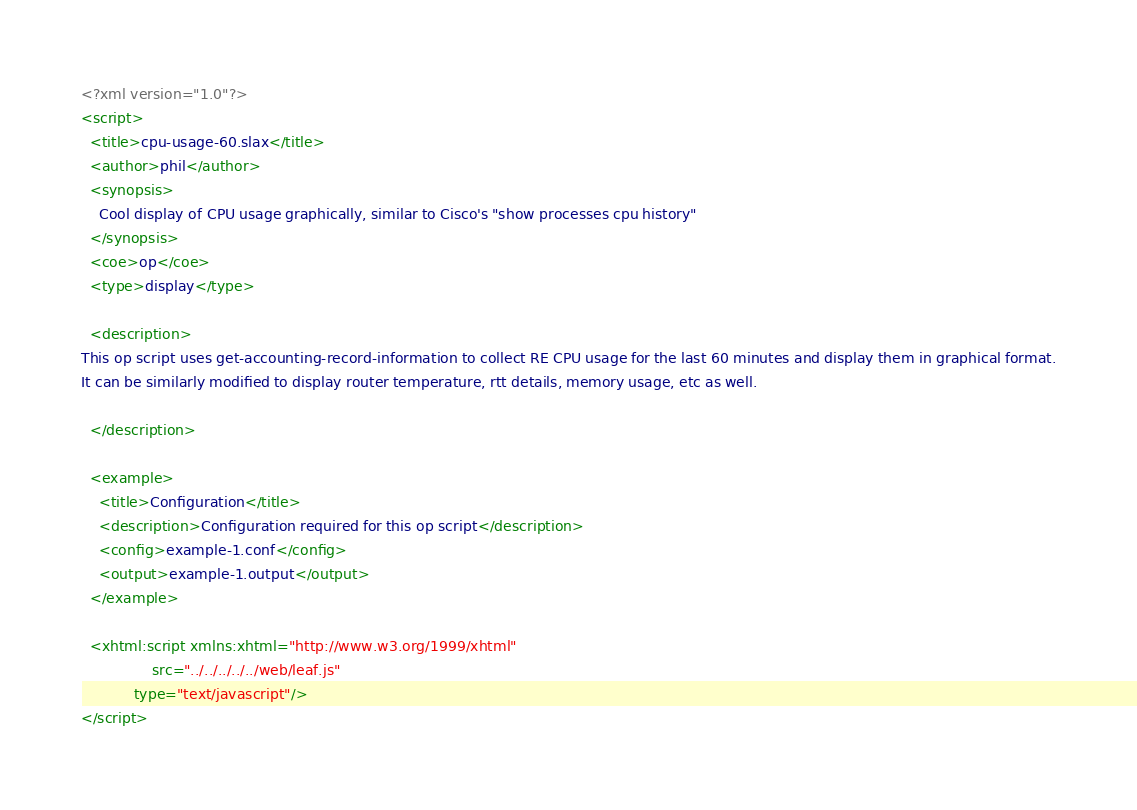<code> <loc_0><loc_0><loc_500><loc_500><_XML_><?xml version="1.0"?>
<script>
  <title>cpu-usage-60.slax</title>
  <author>phil</author>
  <synopsis>
	Cool display of CPU usage graphically, similar to Cisco's "show processes cpu history"
  </synopsis>
  <coe>op</coe>
  <type>display</type>

  <description>
This op script uses get-accounting-record-information to collect RE CPU usage for the last 60 minutes and display them in graphical format.
It can be similarly modified to display router temperature, rtt details, memory usage, etc as well.

  </description>

  <example>
    <title>Configuration</title>
    <description>Configuration required for this op script</description>
    <config>example-1.conf</config>
    <output>example-1.output</output>
  </example>

  <xhtml:script xmlns:xhtml="http://www.w3.org/1999/xhtml"
                src="../../../../../web/leaf.js" 
	        type="text/javascript"/>
</script>
</code> 